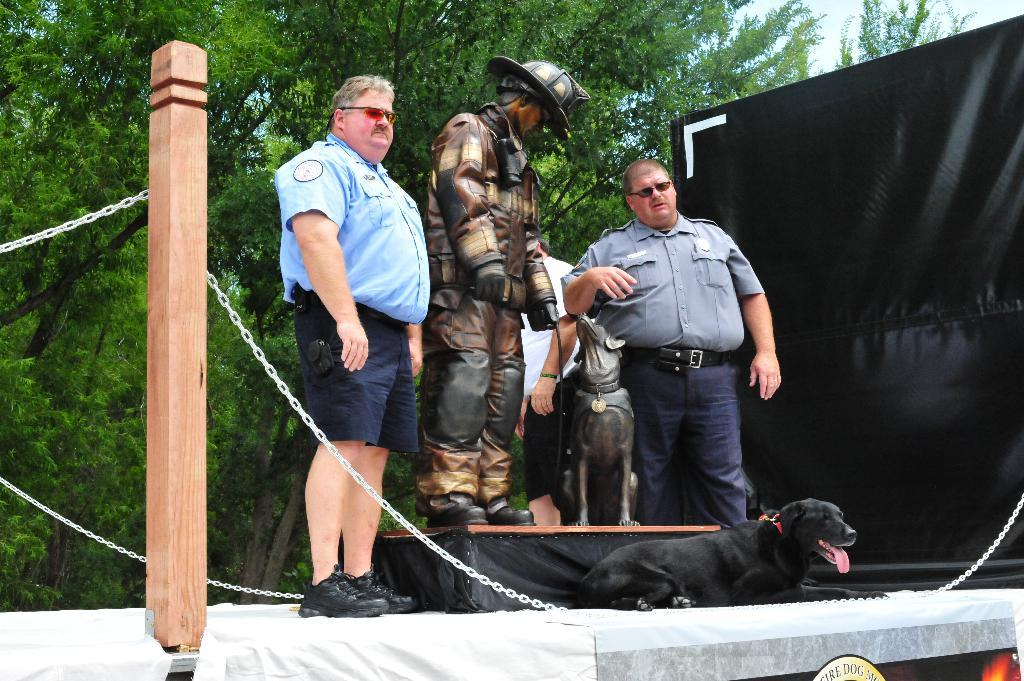How many people are present in the image? There are two persons standing in the image. What other living creature is present in the image? There is a dog in the image. What type of artwork can be seen in the image? There is a sculpture in the image. What can be seen in the background of the image? There are trees and a banner in the background of the image. What type of pancake is being served on the plate in the image? There is no plate or pancake present in the image. What type of jewel is the dog wearing in the image? There is no jewel present in the image, and the dog is not wearing any accessories. 